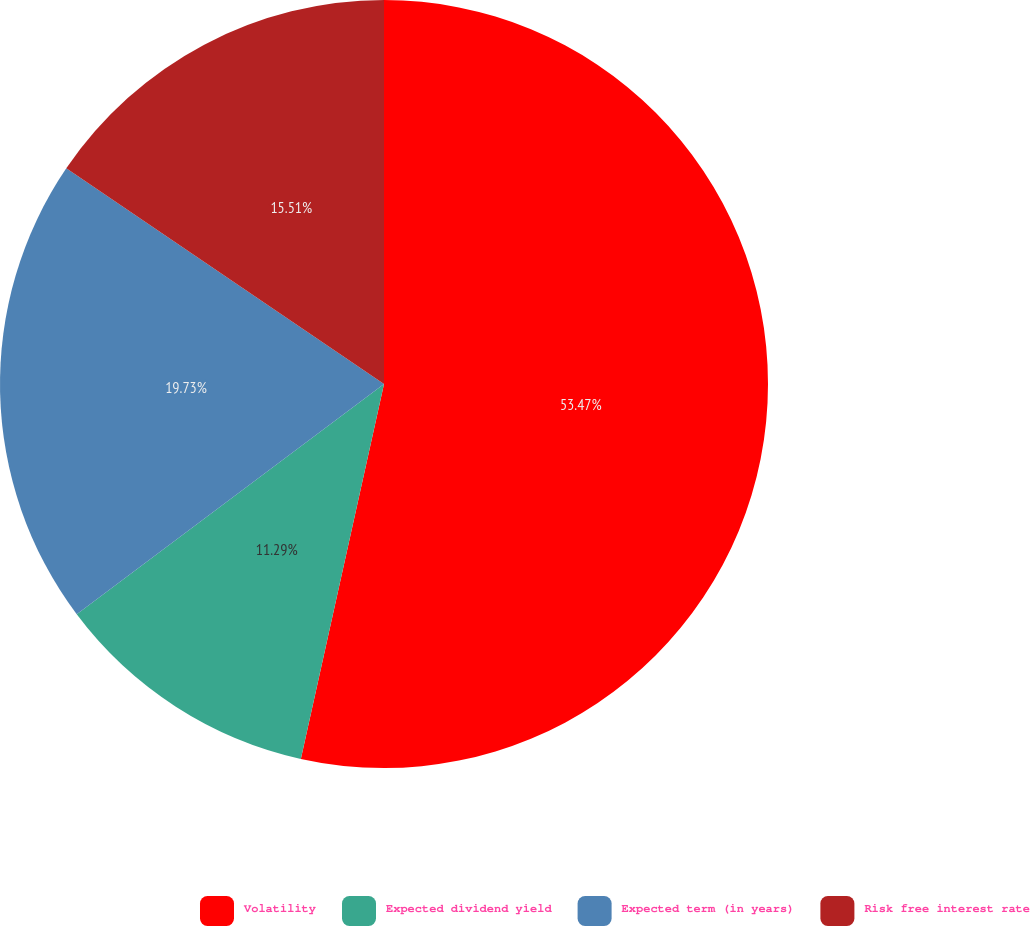Convert chart to OTSL. <chart><loc_0><loc_0><loc_500><loc_500><pie_chart><fcel>Volatility<fcel>Expected dividend yield<fcel>Expected term (in years)<fcel>Risk free interest rate<nl><fcel>53.48%<fcel>11.29%<fcel>19.73%<fcel>15.51%<nl></chart> 